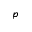<formula> <loc_0><loc_0><loc_500><loc_500>p</formula> 